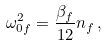<formula> <loc_0><loc_0><loc_500><loc_500>\omega _ { 0 f } ^ { 2 } = \frac { \beta _ { f } } { 1 2 } n _ { f } \, ,</formula> 